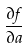<formula> <loc_0><loc_0><loc_500><loc_500>\frac { \partial f } { \partial a }</formula> 